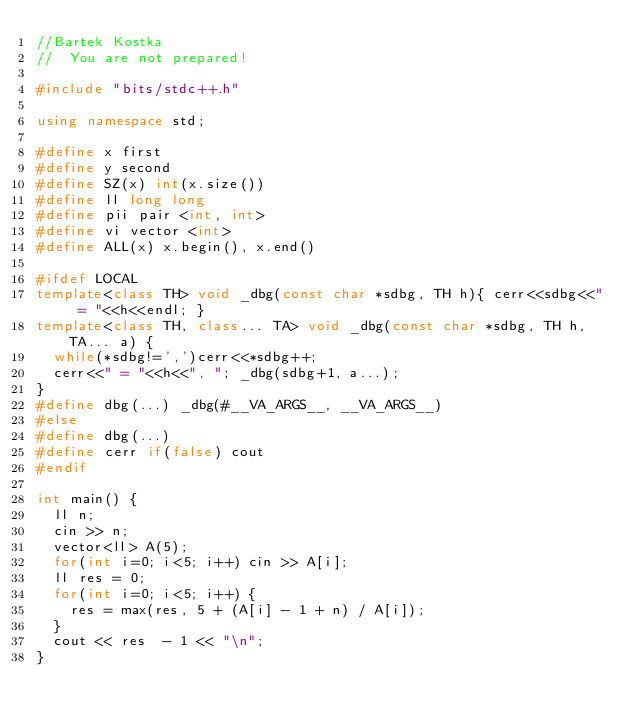Convert code to text. <code><loc_0><loc_0><loc_500><loc_500><_C++_>//Bartek Kostka
//  You are not prepared!

#include "bits/stdc++.h"

using namespace std;

#define x first
#define y second
#define SZ(x) int(x.size())
#define ll long long
#define pii pair <int, int>
#define vi vector <int>
#define ALL(x) x.begin(), x.end()

#ifdef LOCAL
template<class TH> void _dbg(const char *sdbg, TH h){ cerr<<sdbg<<" = "<<h<<endl; }
template<class TH, class... TA> void _dbg(const char *sdbg, TH h, TA... a) {
  while(*sdbg!=',')cerr<<*sdbg++;
  cerr<<" = "<<h<<", "; _dbg(sdbg+1, a...);
}
#define dbg(...) _dbg(#__VA_ARGS__, __VA_ARGS__)
#else
#define dbg(...)
#define cerr if(false) cout
#endif

int main() {
  ll n;
  cin >> n;
  vector<ll> A(5);
  for(int i=0; i<5; i++) cin >> A[i];
  ll res = 0;
  for(int i=0; i<5; i++) {
    res = max(res, 5 + (A[i] - 1 + n) / A[i]);
  }
  cout << res  - 1 << "\n";
}
</code> 